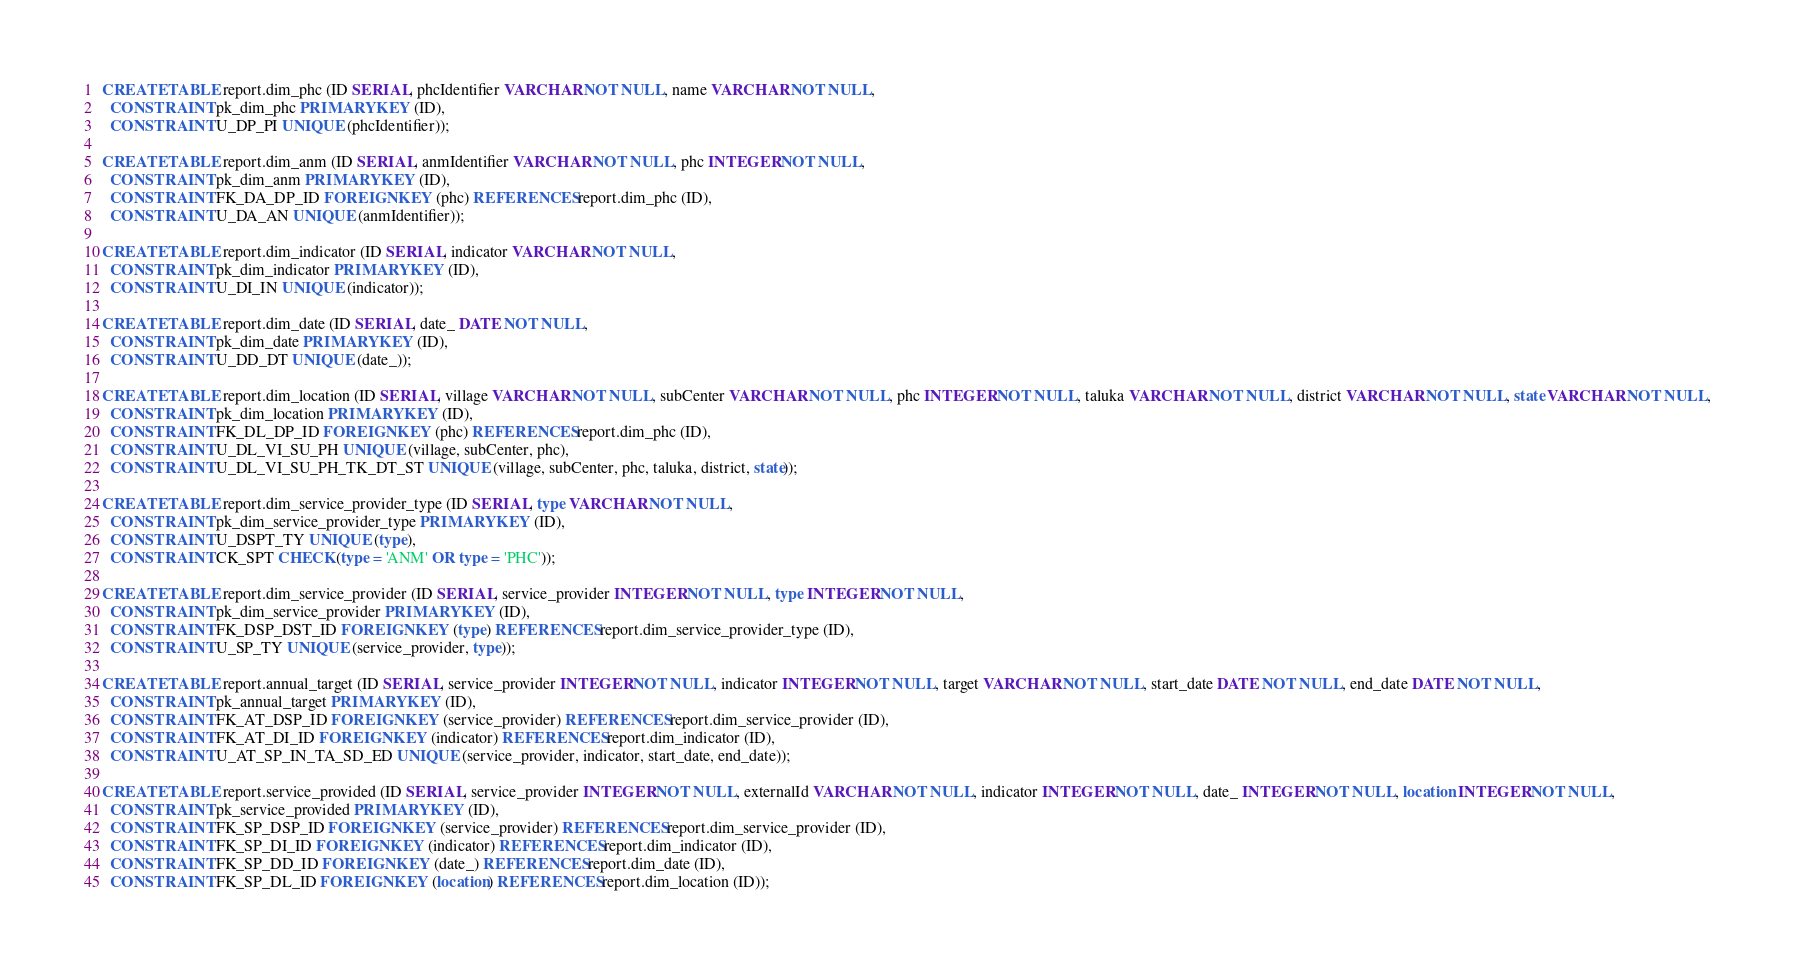Convert code to text. <code><loc_0><loc_0><loc_500><loc_500><_SQL_>CREATE TABLE report.dim_phc (ID SERIAL, phcIdentifier VARCHAR NOT NULL, name VARCHAR NOT NULL,
  CONSTRAINT pk_dim_phc PRIMARY KEY (ID),
  CONSTRAINT U_DP_PI UNIQUE (phcIdentifier));

CREATE TABLE report.dim_anm (ID SERIAL, anmIdentifier VARCHAR NOT NULL, phc INTEGER NOT NULL,
  CONSTRAINT pk_dim_anm PRIMARY KEY (ID),
  CONSTRAINT FK_DA_DP_ID FOREIGN KEY (phc) REFERENCES report.dim_phc (ID),
  CONSTRAINT U_DA_AN UNIQUE (anmIdentifier));

CREATE TABLE report.dim_indicator (ID SERIAL, indicator VARCHAR NOT NULL,
  CONSTRAINT pk_dim_indicator PRIMARY KEY (ID),
  CONSTRAINT U_DI_IN UNIQUE (indicator));

CREATE TABLE report.dim_date (ID SERIAL, date_ DATE NOT NULL,
  CONSTRAINT pk_dim_date PRIMARY KEY (ID),
  CONSTRAINT U_DD_DT UNIQUE (date_));

CREATE TABLE report.dim_location (ID SERIAL, village VARCHAR NOT NULL, subCenter VARCHAR NOT NULL, phc INTEGER NOT NULL, taluka VARCHAR NOT NULL, district VARCHAR NOT NULL, state VARCHAR NOT NULL,
  CONSTRAINT pk_dim_location PRIMARY KEY (ID),
  CONSTRAINT FK_DL_DP_ID FOREIGN KEY (phc) REFERENCES report.dim_phc (ID),
  CONSTRAINT U_DL_VI_SU_PH UNIQUE (village, subCenter, phc),
  CONSTRAINT U_DL_VI_SU_PH_TK_DT_ST UNIQUE (village, subCenter, phc, taluka, district, state));

CREATE TABLE report.dim_service_provider_type (ID SERIAL, type VARCHAR NOT NULL,
  CONSTRAINT pk_dim_service_provider_type PRIMARY KEY (ID),
  CONSTRAINT U_DSPT_TY UNIQUE (type),
  CONSTRAINT CK_SPT CHECK (type = 'ANM' OR type = 'PHC'));

CREATE TABLE report.dim_service_provider (ID SERIAL, service_provider INTEGER NOT NULL, type INTEGER NOT NULL,
  CONSTRAINT pk_dim_service_provider PRIMARY KEY (ID),
  CONSTRAINT FK_DSP_DST_ID FOREIGN KEY (type) REFERENCES report.dim_service_provider_type (ID),
  CONSTRAINT U_SP_TY UNIQUE (service_provider, type));

CREATE TABLE report.annual_target (ID SERIAL, service_provider INTEGER NOT NULL, indicator INTEGER NOT NULL, target VARCHAR NOT NULL, start_date DATE NOT NULL, end_date DATE NOT NULL,
  CONSTRAINT pk_annual_target PRIMARY KEY (ID),
  CONSTRAINT FK_AT_DSP_ID FOREIGN KEY (service_provider) REFERENCES report.dim_service_provider (ID),
  CONSTRAINT FK_AT_DI_ID FOREIGN KEY (indicator) REFERENCES report.dim_indicator (ID),
  CONSTRAINT U_AT_SP_IN_TA_SD_ED UNIQUE (service_provider, indicator, start_date, end_date));

CREATE TABLE report.service_provided (ID SERIAL, service_provider INTEGER NOT NULL, externalId VARCHAR NOT NULL, indicator INTEGER NOT NULL, date_ INTEGER NOT NULL, location INTEGER NOT NULL,
  CONSTRAINT pk_service_provided PRIMARY KEY (ID),
  CONSTRAINT FK_SP_DSP_ID FOREIGN KEY (service_provider) REFERENCES report.dim_service_provider (ID),
  CONSTRAINT FK_SP_DI_ID FOREIGN KEY (indicator) REFERENCES report.dim_indicator (ID),
  CONSTRAINT FK_SP_DD_ID FOREIGN KEY (date_) REFERENCES report.dim_date (ID),
  CONSTRAINT FK_SP_DL_ID FOREIGN KEY (location) REFERENCES report.dim_location (ID));
</code> 